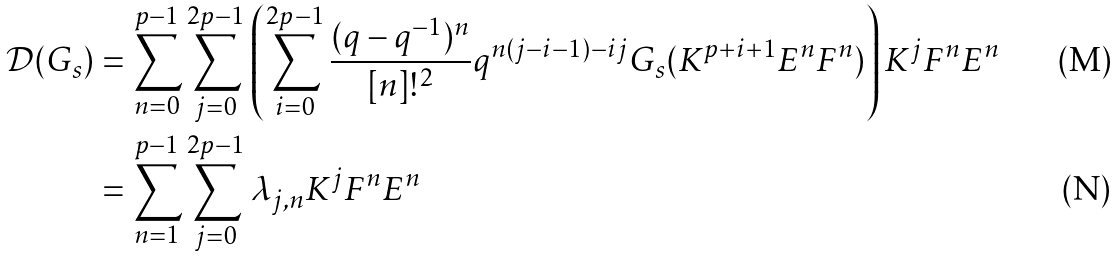<formula> <loc_0><loc_0><loc_500><loc_500>\mathcal { D } ( G _ { s } ) & = \sum _ { n = 0 } ^ { p - 1 } \sum _ { j = 0 } ^ { 2 p - 1 } \left ( \sum _ { i = 0 } ^ { 2 p - 1 } \frac { ( q - q ^ { - 1 } ) ^ { n } } { [ n ] ! ^ { 2 } } q ^ { n ( j - i - 1 ) - i j } G _ { s } ( K ^ { p + i + 1 } E ^ { n } F ^ { n } ) \right ) K ^ { j } F ^ { n } E ^ { n } \\ & = \sum _ { n = 1 } ^ { p - 1 } \sum _ { j = 0 } ^ { 2 p - 1 } \lambda _ { j , n } K ^ { j } F ^ { n } E ^ { n }</formula> 